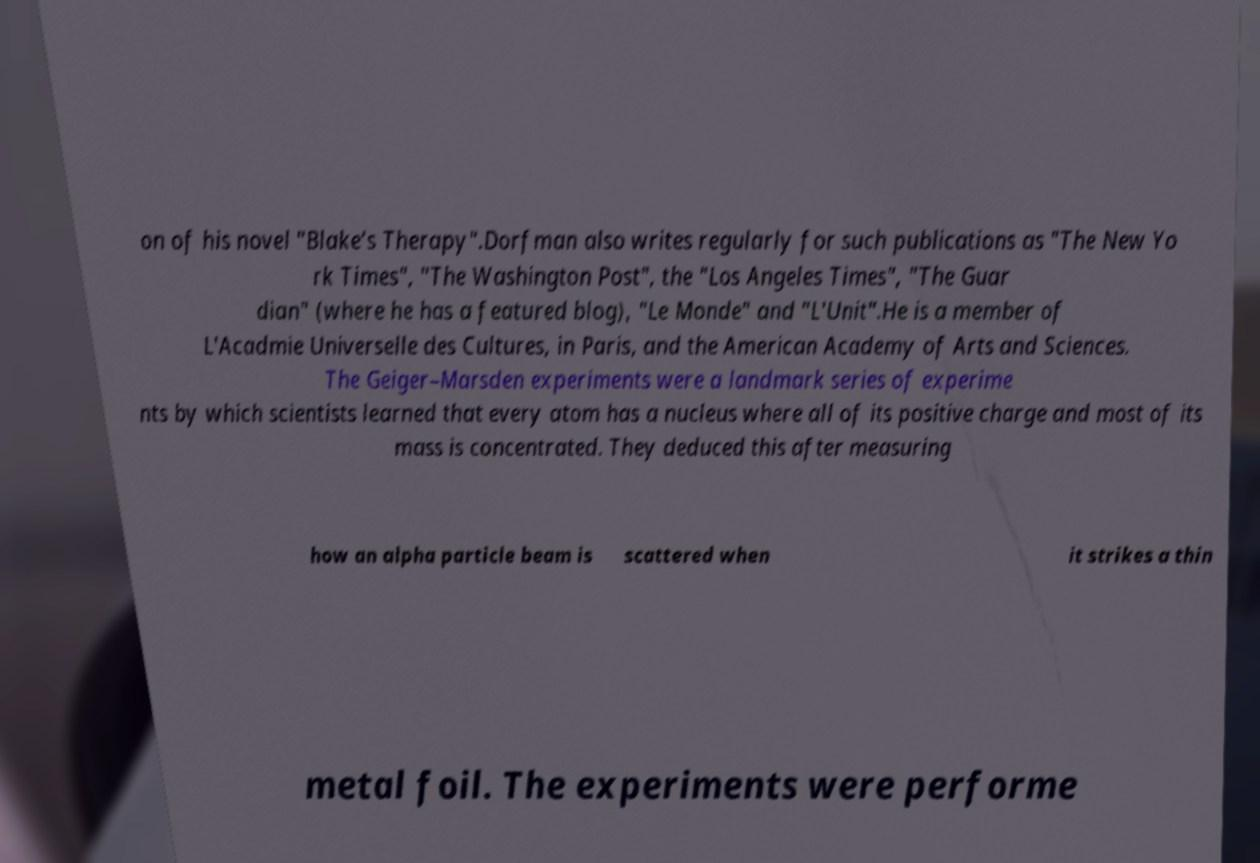Can you read and provide the text displayed in the image?This photo seems to have some interesting text. Can you extract and type it out for me? on of his novel "Blake’s Therapy".Dorfman also writes regularly for such publications as "The New Yo rk Times", "The Washington Post", the "Los Angeles Times", "The Guar dian" (where he has a featured blog), "Le Monde" and "L'Unit".He is a member of L'Acadmie Universelle des Cultures, in Paris, and the American Academy of Arts and Sciences. The Geiger–Marsden experiments were a landmark series of experime nts by which scientists learned that every atom has a nucleus where all of its positive charge and most of its mass is concentrated. They deduced this after measuring how an alpha particle beam is scattered when it strikes a thin metal foil. The experiments were performe 